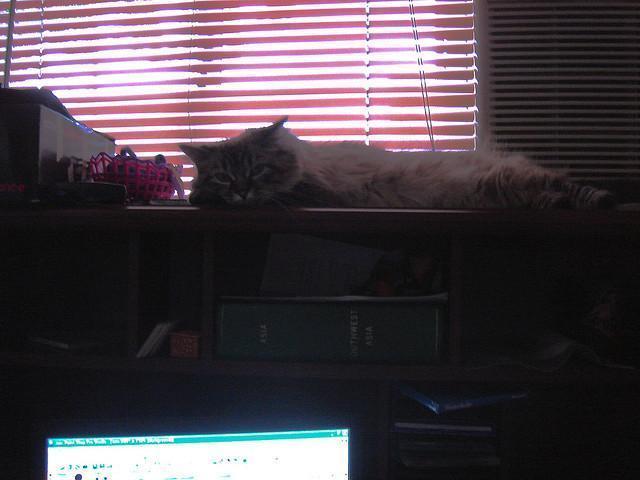How many books are there?
Give a very brief answer. 3. How many tvs can you see?
Give a very brief answer. 1. 